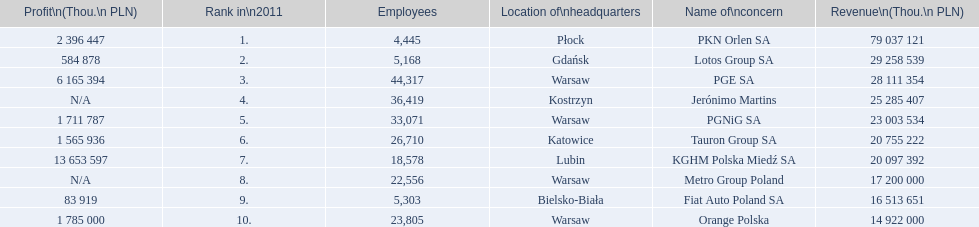What is the number of employees that work for pkn orlen sa in poland? 4,445. What number of employees work for lotos group sa? 5,168. How many people work for pgnig sa? 33,071. 